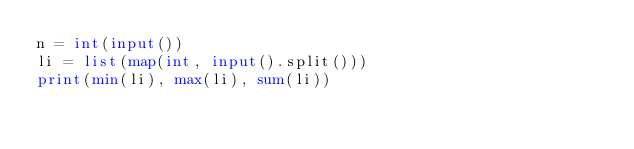<code> <loc_0><loc_0><loc_500><loc_500><_Python_>n = int(input())
li = list(map(int, input().split()))
print(min(li), max(li), sum(li))
</code> 